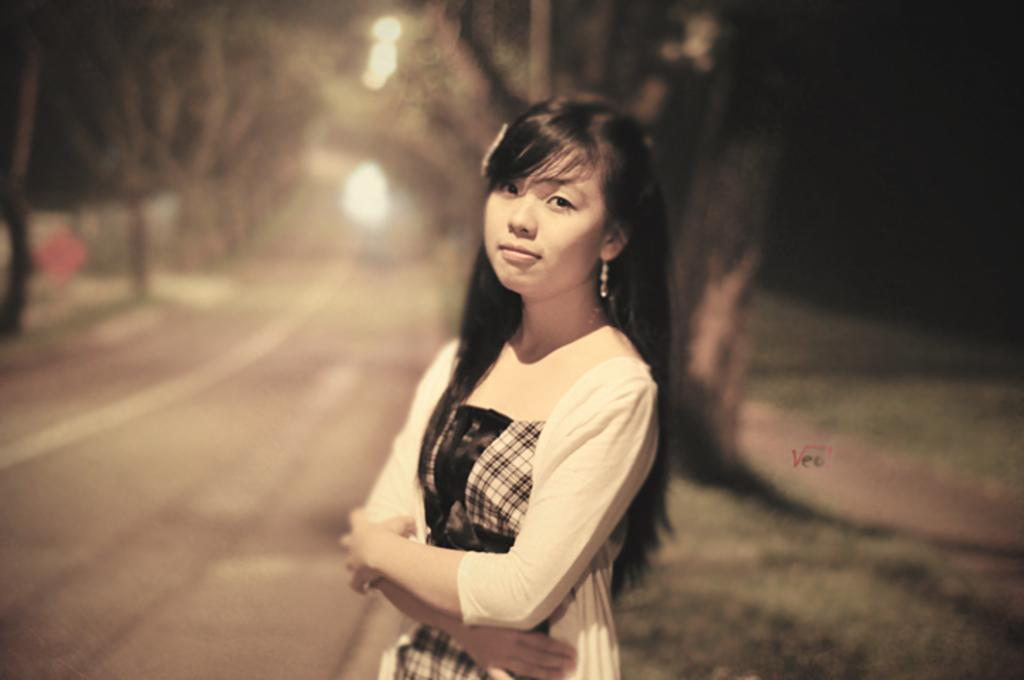What is the main subject of the image? There is a person in the image. Can you describe the person's appearance? The person is wearing clothes. What can be observed about the background of the image? The background of the image is blurred. How many planes are visible in the image? There are no planes visible in the image; it features a person with a blurred background. Is there a balloon being held by the person in the image? There is no balloon present in the image. 